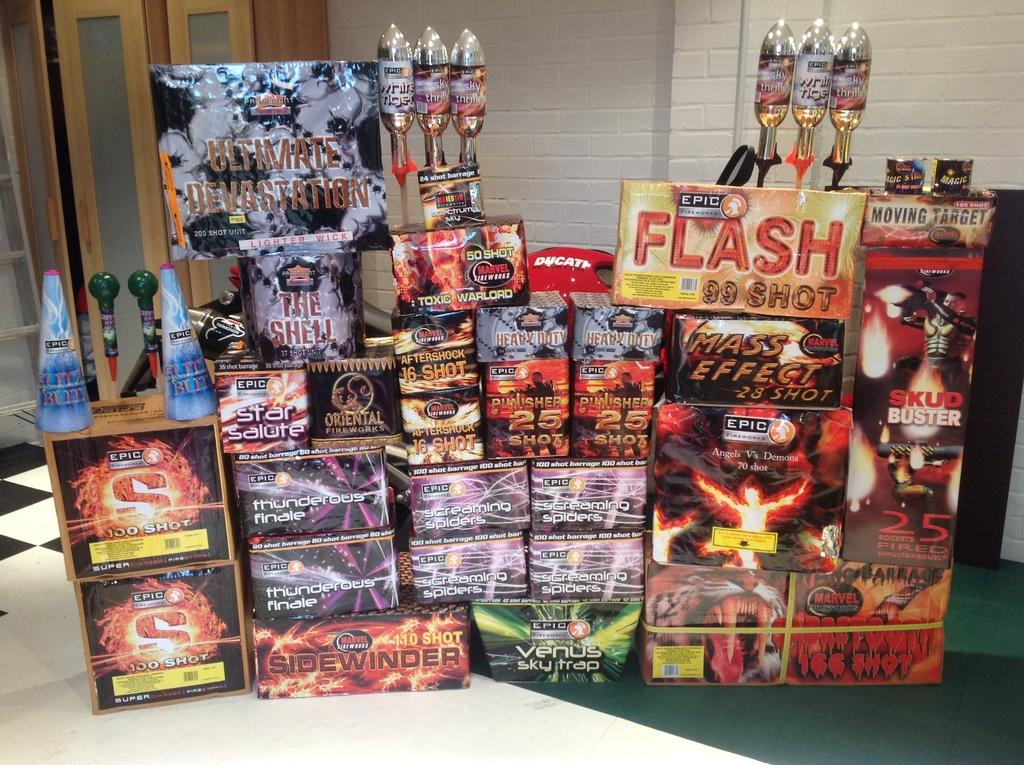<image>
Share a concise interpretation of the image provided. A display of items featuring many items made by Epic. 